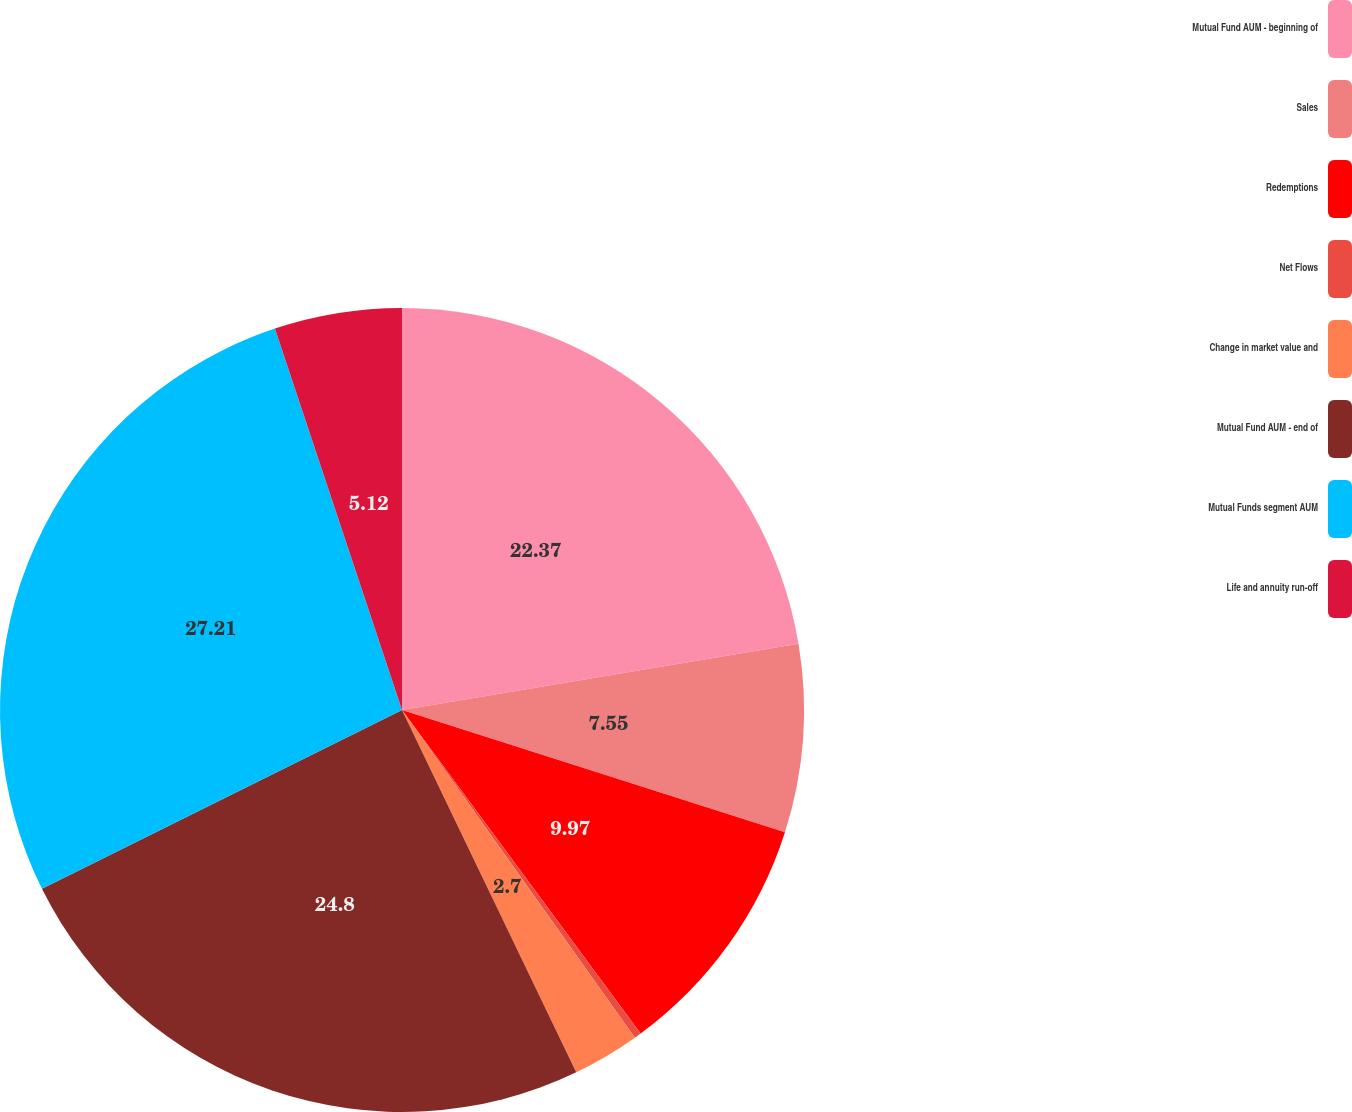Convert chart to OTSL. <chart><loc_0><loc_0><loc_500><loc_500><pie_chart><fcel>Mutual Fund AUM - beginning of<fcel>Sales<fcel>Redemptions<fcel>Net Flows<fcel>Change in market value and<fcel>Mutual Fund AUM - end of<fcel>Mutual Funds segment AUM<fcel>Life and annuity run-off<nl><fcel>22.37%<fcel>7.55%<fcel>9.97%<fcel>0.28%<fcel>2.7%<fcel>24.8%<fcel>27.22%<fcel>5.12%<nl></chart> 